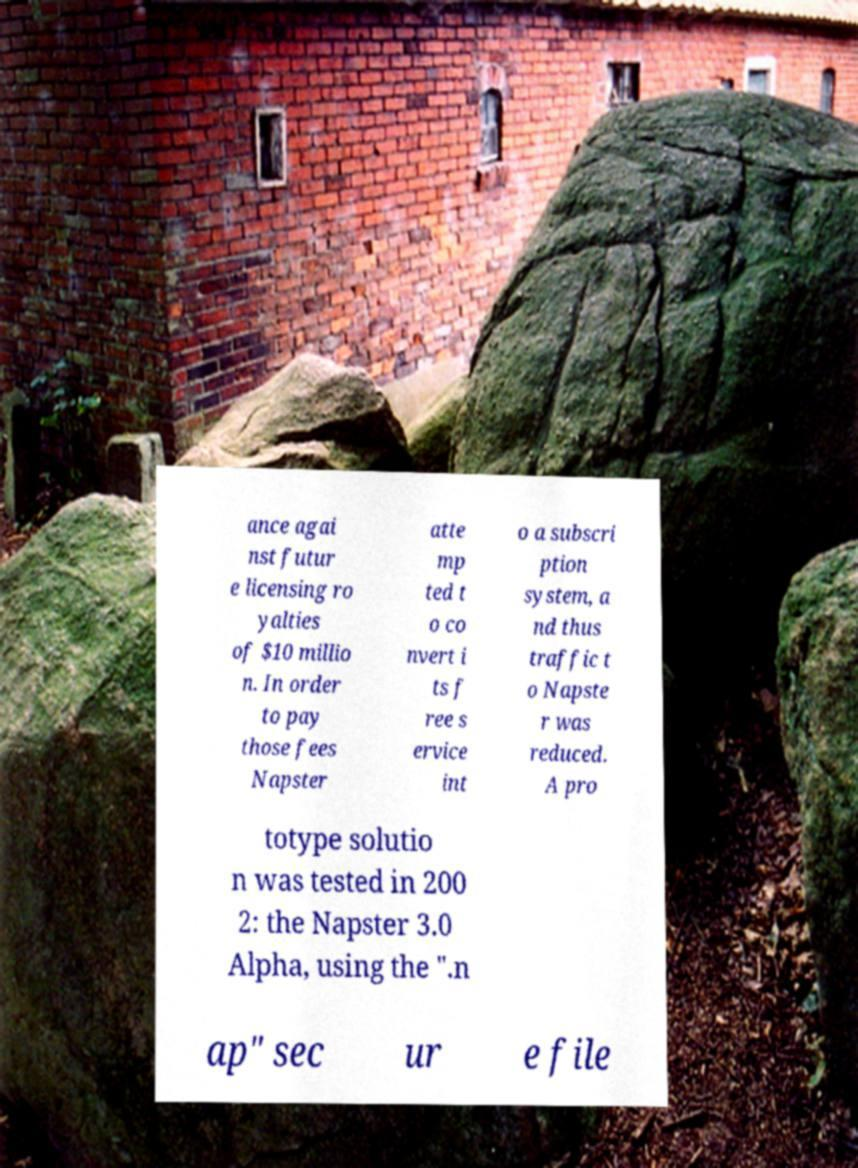There's text embedded in this image that I need extracted. Can you transcribe it verbatim? ance agai nst futur e licensing ro yalties of $10 millio n. In order to pay those fees Napster atte mp ted t o co nvert i ts f ree s ervice int o a subscri ption system, a nd thus traffic t o Napste r was reduced. A pro totype solutio n was tested in 200 2: the Napster 3.0 Alpha, using the ".n ap" sec ur e file 